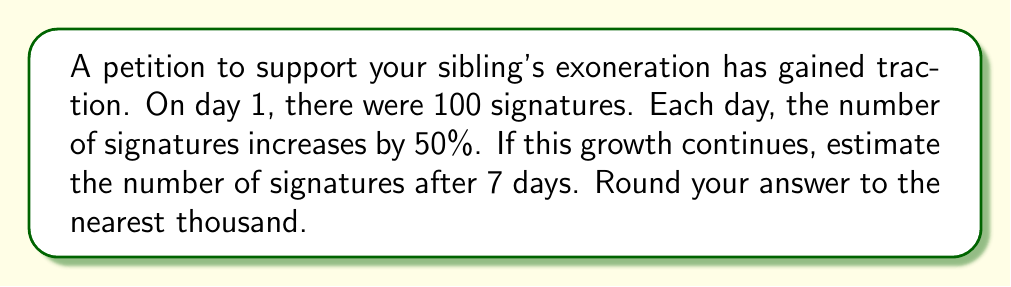Help me with this question. Let's approach this step-by-step:

1) The initial number of signatures is 100.

2) Each day, the number increases by 50%, which means it's multiplied by 1.5.

3) We can represent this growth using an exponential function:
   $$ S = 100 \cdot 1.5^{d} $$
   where $S$ is the number of signatures and $d$ is the number of days.

4) We want to find $S$ when $d = 7$:
   $$ S = 100 \cdot 1.5^7 $$

5) Let's calculate this:
   $$ S = 100 \cdot 1.5^7 $$
   $$ = 100 \cdot 17.0859375 $$
   $$ = 1708.59375 $$

6) Rounding to the nearest thousand:
   1708.59375 ≈ 2000

Therefore, after 7 days, we estimate there will be approximately 2000 signatures.
Answer: 2000 signatures 